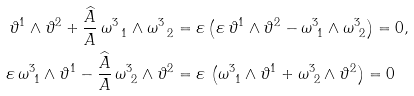<formula> <loc_0><loc_0><loc_500><loc_500>\vartheta ^ { 1 } \wedge \vartheta ^ { 2 } + \frac { \widehat { A } } { A } \, \omega ^ { 3 } _ { \ 1 } \wedge \omega ^ { 3 } _ { \ 2 } & = \varepsilon \left ( \varepsilon \, \vartheta ^ { 1 } \wedge \vartheta ^ { 2 } - \omega ^ { 3 } _ { \ 1 } \wedge \omega ^ { 3 } _ { \ 2 } \right ) = 0 , \\ \varepsilon \, \omega ^ { 3 } _ { \ 1 } \wedge \vartheta ^ { 1 } - \frac { \widehat { A } } { A } \, \omega ^ { 3 } _ { \ 2 } \wedge \vartheta ^ { 2 } & = \varepsilon \, \left ( \omega ^ { 3 } _ { \ 1 } \wedge \vartheta ^ { 1 } + \omega ^ { 3 } _ { \ 2 } \wedge \vartheta ^ { 2 } \right ) = 0</formula> 